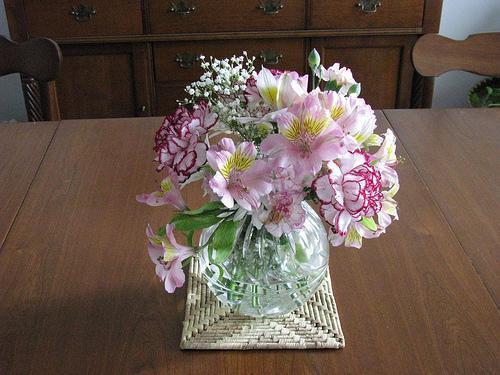How many chairs are in the photo?
Give a very brief answer. 2. 